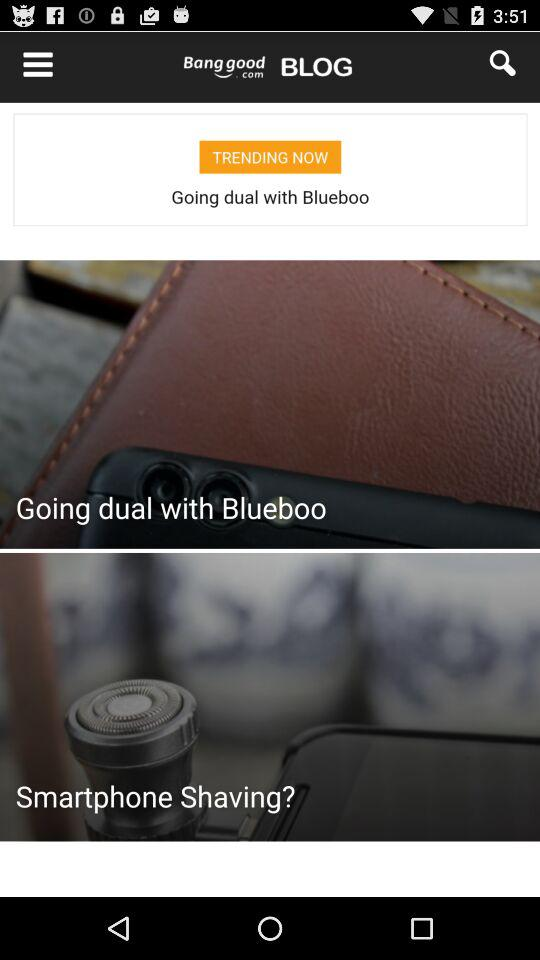How many likes of the "Maxi Skirt" are there? There are 606 likes of the "Maxi Skirt". 